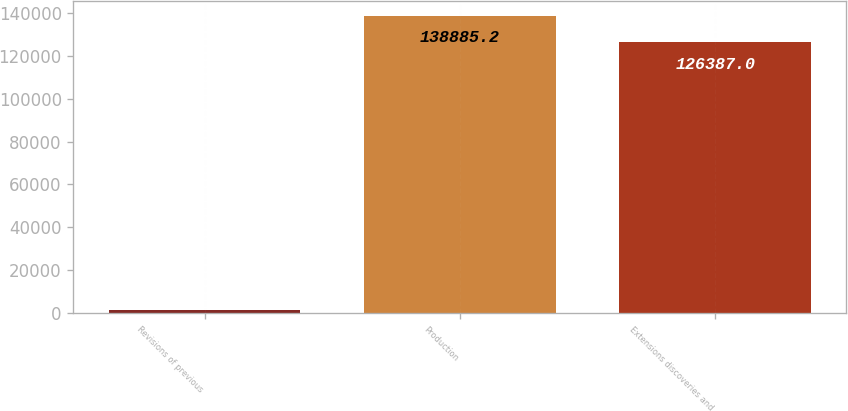<chart> <loc_0><loc_0><loc_500><loc_500><bar_chart><fcel>Revisions of previous<fcel>Production<fcel>Extensions discoveries and<nl><fcel>1533<fcel>138885<fcel>126387<nl></chart> 